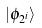<formula> <loc_0><loc_0><loc_500><loc_500>| \phi _ { 2 ^ { i } } \rangle</formula> 